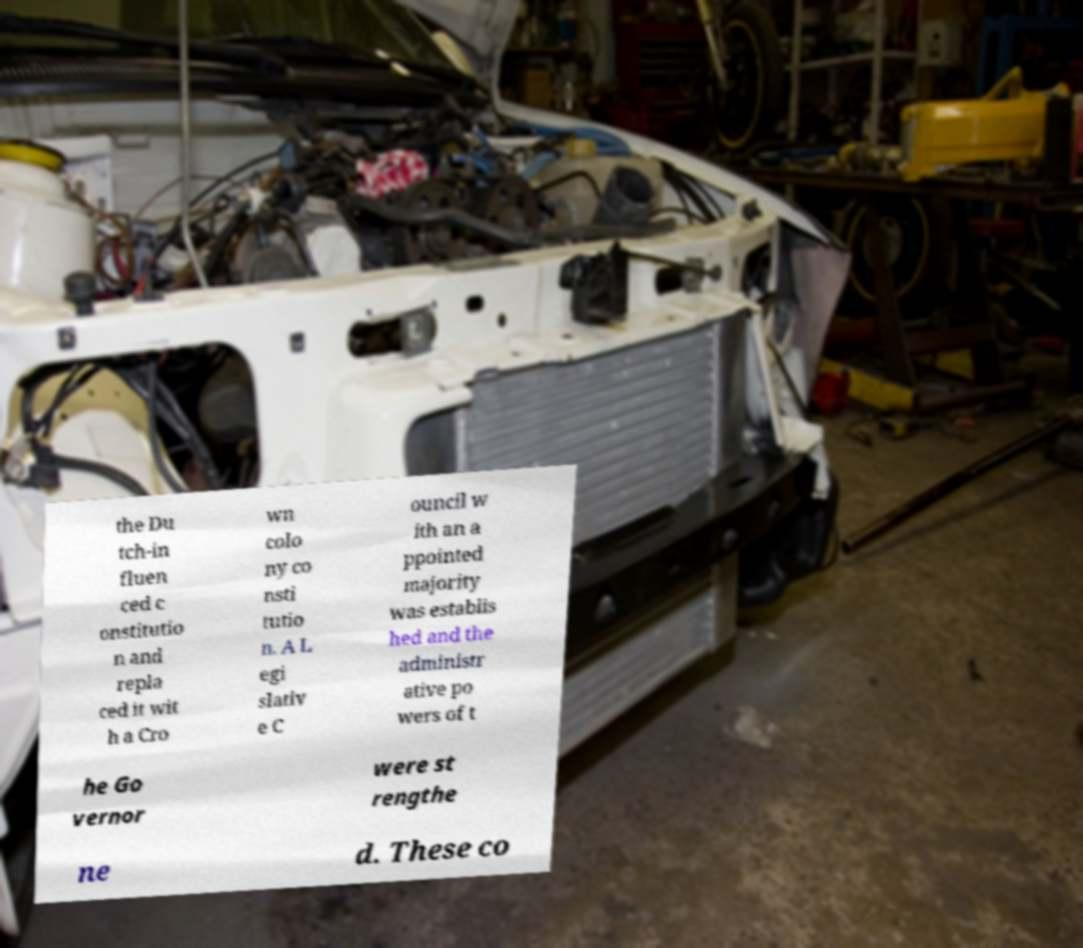Can you accurately transcribe the text from the provided image for me? the Du tch-in fluen ced c onstitutio n and repla ced it wit h a Cro wn colo ny co nsti tutio n. A L egi slativ e C ouncil w ith an a ppointed majority was establis hed and the administr ative po wers of t he Go vernor were st rengthe ne d. These co 